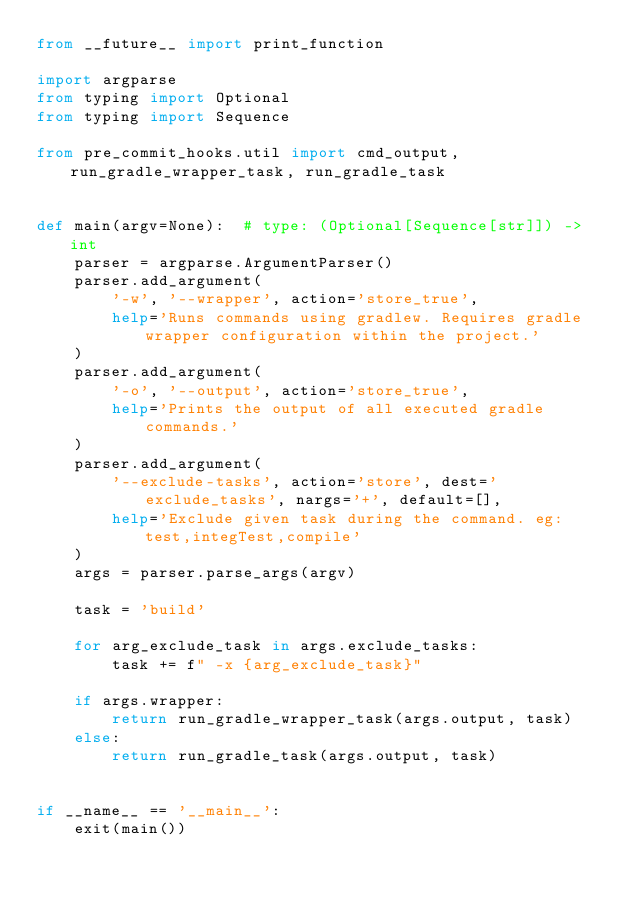<code> <loc_0><loc_0><loc_500><loc_500><_Python_>from __future__ import print_function

import argparse
from typing import Optional
from typing import Sequence

from pre_commit_hooks.util import cmd_output, run_gradle_wrapper_task, run_gradle_task


def main(argv=None):  # type: (Optional[Sequence[str]]) -> int
    parser = argparse.ArgumentParser()
    parser.add_argument(
        '-w', '--wrapper', action='store_true',
        help='Runs commands using gradlew. Requires gradle wrapper configuration within the project.'
    )
    parser.add_argument(
        '-o', '--output', action='store_true',
        help='Prints the output of all executed gradle commands.'
    )
    parser.add_argument(
        '--exclude-tasks', action='store', dest='exclude_tasks', nargs='+', default=[],
        help='Exclude given task during the command. eg: test,integTest,compile'
    )
    args = parser.parse_args(argv)

    task = 'build'

    for arg_exclude_task in args.exclude_tasks:
        task += f" -x {arg_exclude_task}"

    if args.wrapper:
        return run_gradle_wrapper_task(args.output, task)
    else:
        return run_gradle_task(args.output, task)


if __name__ == '__main__':
    exit(main())
</code> 